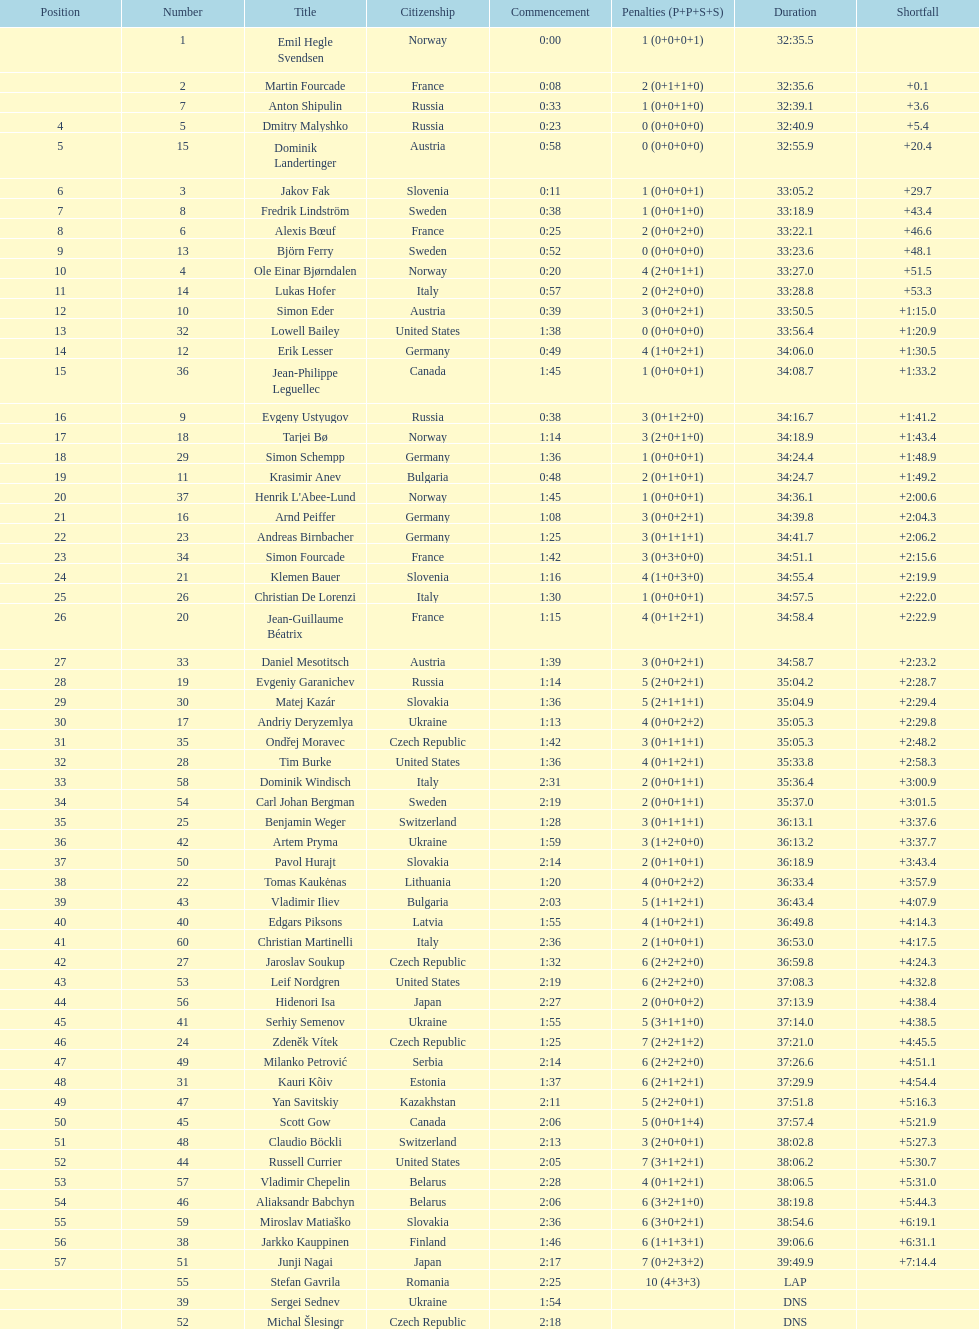What is the total number of participants between norway and france? 7. Could you help me parse every detail presented in this table? {'header': ['Position', 'Number', 'Title', 'Citizenship', 'Commencement', 'Penalties (P+P+S+S)', 'Duration', 'Shortfall'], 'rows': [['', '1', 'Emil Hegle Svendsen', 'Norway', '0:00', '1 (0+0+0+1)', '32:35.5', ''], ['', '2', 'Martin Fourcade', 'France', '0:08', '2 (0+1+1+0)', '32:35.6', '+0.1'], ['', '7', 'Anton Shipulin', 'Russia', '0:33', '1 (0+0+1+0)', '32:39.1', '+3.6'], ['4', '5', 'Dmitry Malyshko', 'Russia', '0:23', '0 (0+0+0+0)', '32:40.9', '+5.4'], ['5', '15', 'Dominik Landertinger', 'Austria', '0:58', '0 (0+0+0+0)', '32:55.9', '+20.4'], ['6', '3', 'Jakov Fak', 'Slovenia', '0:11', '1 (0+0+0+1)', '33:05.2', '+29.7'], ['7', '8', 'Fredrik Lindström', 'Sweden', '0:38', '1 (0+0+1+0)', '33:18.9', '+43.4'], ['8', '6', 'Alexis Bœuf', 'France', '0:25', '2 (0+0+2+0)', '33:22.1', '+46.6'], ['9', '13', 'Björn Ferry', 'Sweden', '0:52', '0 (0+0+0+0)', '33:23.6', '+48.1'], ['10', '4', 'Ole Einar Bjørndalen', 'Norway', '0:20', '4 (2+0+1+1)', '33:27.0', '+51.5'], ['11', '14', 'Lukas Hofer', 'Italy', '0:57', '2 (0+2+0+0)', '33:28.8', '+53.3'], ['12', '10', 'Simon Eder', 'Austria', '0:39', '3 (0+0+2+1)', '33:50.5', '+1:15.0'], ['13', '32', 'Lowell Bailey', 'United States', '1:38', '0 (0+0+0+0)', '33:56.4', '+1:20.9'], ['14', '12', 'Erik Lesser', 'Germany', '0:49', '4 (1+0+2+1)', '34:06.0', '+1:30.5'], ['15', '36', 'Jean-Philippe Leguellec', 'Canada', '1:45', '1 (0+0+0+1)', '34:08.7', '+1:33.2'], ['16', '9', 'Evgeny Ustyugov', 'Russia', '0:38', '3 (0+1+2+0)', '34:16.7', '+1:41.2'], ['17', '18', 'Tarjei Bø', 'Norway', '1:14', '3 (2+0+1+0)', '34:18.9', '+1:43.4'], ['18', '29', 'Simon Schempp', 'Germany', '1:36', '1 (0+0+0+1)', '34:24.4', '+1:48.9'], ['19', '11', 'Krasimir Anev', 'Bulgaria', '0:48', '2 (0+1+0+1)', '34:24.7', '+1:49.2'], ['20', '37', "Henrik L'Abee-Lund", 'Norway', '1:45', '1 (0+0+0+1)', '34:36.1', '+2:00.6'], ['21', '16', 'Arnd Peiffer', 'Germany', '1:08', '3 (0+0+2+1)', '34:39.8', '+2:04.3'], ['22', '23', 'Andreas Birnbacher', 'Germany', '1:25', '3 (0+1+1+1)', '34:41.7', '+2:06.2'], ['23', '34', 'Simon Fourcade', 'France', '1:42', '3 (0+3+0+0)', '34:51.1', '+2:15.6'], ['24', '21', 'Klemen Bauer', 'Slovenia', '1:16', '4 (1+0+3+0)', '34:55.4', '+2:19.9'], ['25', '26', 'Christian De Lorenzi', 'Italy', '1:30', '1 (0+0+0+1)', '34:57.5', '+2:22.0'], ['26', '20', 'Jean-Guillaume Béatrix', 'France', '1:15', '4 (0+1+2+1)', '34:58.4', '+2:22.9'], ['27', '33', 'Daniel Mesotitsch', 'Austria', '1:39', '3 (0+0+2+1)', '34:58.7', '+2:23.2'], ['28', '19', 'Evgeniy Garanichev', 'Russia', '1:14', '5 (2+0+2+1)', '35:04.2', '+2:28.7'], ['29', '30', 'Matej Kazár', 'Slovakia', '1:36', '5 (2+1+1+1)', '35:04.9', '+2:29.4'], ['30', '17', 'Andriy Deryzemlya', 'Ukraine', '1:13', '4 (0+0+2+2)', '35:05.3', '+2:29.8'], ['31', '35', 'Ondřej Moravec', 'Czech Republic', '1:42', '3 (0+1+1+1)', '35:05.3', '+2:48.2'], ['32', '28', 'Tim Burke', 'United States', '1:36', '4 (0+1+2+1)', '35:33.8', '+2:58.3'], ['33', '58', 'Dominik Windisch', 'Italy', '2:31', '2 (0+0+1+1)', '35:36.4', '+3:00.9'], ['34', '54', 'Carl Johan Bergman', 'Sweden', '2:19', '2 (0+0+1+1)', '35:37.0', '+3:01.5'], ['35', '25', 'Benjamin Weger', 'Switzerland', '1:28', '3 (0+1+1+1)', '36:13.1', '+3:37.6'], ['36', '42', 'Artem Pryma', 'Ukraine', '1:59', '3 (1+2+0+0)', '36:13.2', '+3:37.7'], ['37', '50', 'Pavol Hurajt', 'Slovakia', '2:14', '2 (0+1+0+1)', '36:18.9', '+3:43.4'], ['38', '22', 'Tomas Kaukėnas', 'Lithuania', '1:20', '4 (0+0+2+2)', '36:33.4', '+3:57.9'], ['39', '43', 'Vladimir Iliev', 'Bulgaria', '2:03', '5 (1+1+2+1)', '36:43.4', '+4:07.9'], ['40', '40', 'Edgars Piksons', 'Latvia', '1:55', '4 (1+0+2+1)', '36:49.8', '+4:14.3'], ['41', '60', 'Christian Martinelli', 'Italy', '2:36', '2 (1+0+0+1)', '36:53.0', '+4:17.5'], ['42', '27', 'Jaroslav Soukup', 'Czech Republic', '1:32', '6 (2+2+2+0)', '36:59.8', '+4:24.3'], ['43', '53', 'Leif Nordgren', 'United States', '2:19', '6 (2+2+2+0)', '37:08.3', '+4:32.8'], ['44', '56', 'Hidenori Isa', 'Japan', '2:27', '2 (0+0+0+2)', '37:13.9', '+4:38.4'], ['45', '41', 'Serhiy Semenov', 'Ukraine', '1:55', '5 (3+1+1+0)', '37:14.0', '+4:38.5'], ['46', '24', 'Zdeněk Vítek', 'Czech Republic', '1:25', '7 (2+2+1+2)', '37:21.0', '+4:45.5'], ['47', '49', 'Milanko Petrović', 'Serbia', '2:14', '6 (2+2+2+0)', '37:26.6', '+4:51.1'], ['48', '31', 'Kauri Kõiv', 'Estonia', '1:37', '6 (2+1+2+1)', '37:29.9', '+4:54.4'], ['49', '47', 'Yan Savitskiy', 'Kazakhstan', '2:11', '5 (2+2+0+1)', '37:51.8', '+5:16.3'], ['50', '45', 'Scott Gow', 'Canada', '2:06', '5 (0+0+1+4)', '37:57.4', '+5:21.9'], ['51', '48', 'Claudio Böckli', 'Switzerland', '2:13', '3 (2+0+0+1)', '38:02.8', '+5:27.3'], ['52', '44', 'Russell Currier', 'United States', '2:05', '7 (3+1+2+1)', '38:06.2', '+5:30.7'], ['53', '57', 'Vladimir Chepelin', 'Belarus', '2:28', '4 (0+1+2+1)', '38:06.5', '+5:31.0'], ['54', '46', 'Aliaksandr Babchyn', 'Belarus', '2:06', '6 (3+2+1+0)', '38:19.8', '+5:44.3'], ['55', '59', 'Miroslav Matiaško', 'Slovakia', '2:36', '6 (3+0+2+1)', '38:54.6', '+6:19.1'], ['56', '38', 'Jarkko Kauppinen', 'Finland', '1:46', '6 (1+1+3+1)', '39:06.6', '+6:31.1'], ['57', '51', 'Junji Nagai', 'Japan', '2:17', '7 (0+2+3+2)', '39:49.9', '+7:14.4'], ['', '55', 'Stefan Gavrila', 'Romania', '2:25', '10 (4+3+3)', 'LAP', ''], ['', '39', 'Sergei Sednev', 'Ukraine', '1:54', '', 'DNS', ''], ['', '52', 'Michal Šlesingr', 'Czech Republic', '2:18', '', 'DNS', '']]} 